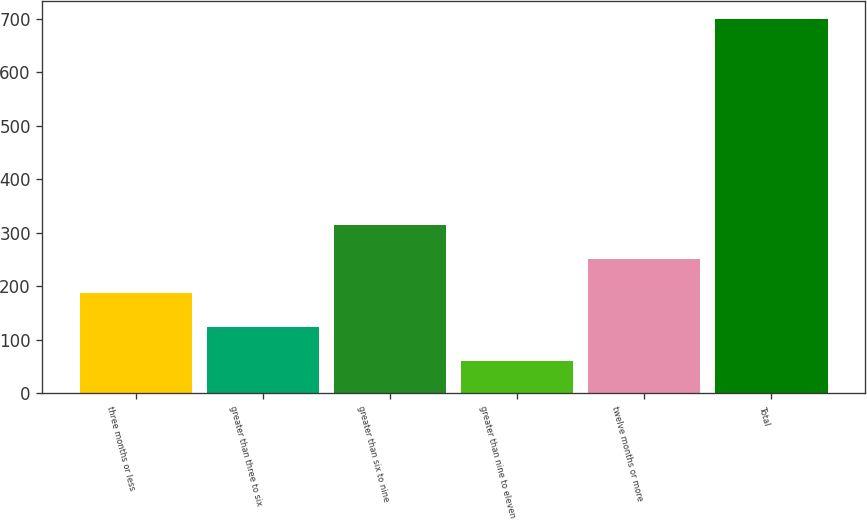Convert chart to OTSL. <chart><loc_0><loc_0><loc_500><loc_500><bar_chart><fcel>three months or less<fcel>greater than three to six<fcel>greater than six to nine<fcel>greater than nine to eleven<fcel>twelve months or more<fcel>Total<nl><fcel>187.8<fcel>123.9<fcel>315.6<fcel>60<fcel>251.7<fcel>699<nl></chart> 